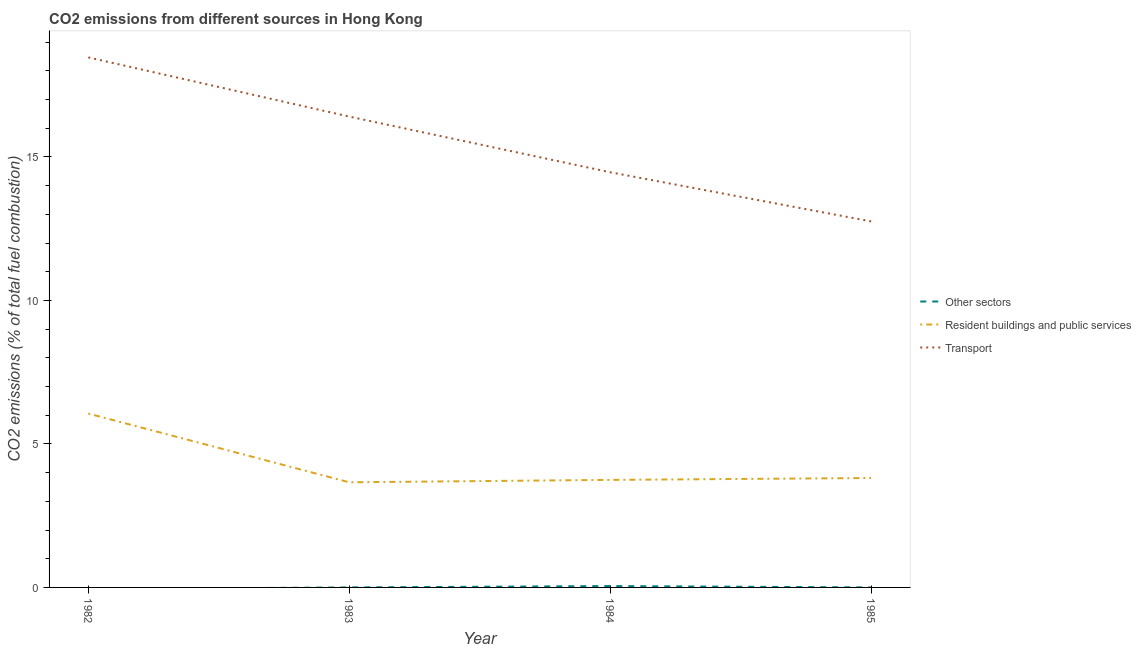What is the percentage of co2 emissions from transport in 1983?
Your answer should be compact. 16.41. Across all years, what is the maximum percentage of co2 emissions from transport?
Give a very brief answer. 18.47. Across all years, what is the minimum percentage of co2 emissions from transport?
Offer a very short reply. 12.76. What is the total percentage of co2 emissions from resident buildings and public services in the graph?
Offer a terse response. 17.28. What is the difference between the percentage of co2 emissions from transport in 1983 and that in 1984?
Make the answer very short. 1.94. What is the difference between the percentage of co2 emissions from other sectors in 1983 and the percentage of co2 emissions from resident buildings and public services in 1984?
Keep it short and to the point. -3.75. What is the average percentage of co2 emissions from other sectors per year?
Keep it short and to the point. 0.01. In the year 1985, what is the difference between the percentage of co2 emissions from resident buildings and public services and percentage of co2 emissions from transport?
Offer a terse response. -8.94. What is the ratio of the percentage of co2 emissions from transport in 1982 to that in 1985?
Offer a terse response. 1.45. Is the percentage of co2 emissions from resident buildings and public services in 1984 less than that in 1985?
Your answer should be compact. Yes. What is the difference between the highest and the second highest percentage of co2 emissions from transport?
Your response must be concise. 2.06. What is the difference between the highest and the lowest percentage of co2 emissions from other sectors?
Make the answer very short. 0.05. Is the sum of the percentage of co2 emissions from transport in 1982 and 1984 greater than the maximum percentage of co2 emissions from other sectors across all years?
Give a very brief answer. Yes. Does the percentage of co2 emissions from transport monotonically increase over the years?
Provide a succinct answer. No. Is the percentage of co2 emissions from transport strictly greater than the percentage of co2 emissions from resident buildings and public services over the years?
Give a very brief answer. Yes. Is the percentage of co2 emissions from transport strictly less than the percentage of co2 emissions from other sectors over the years?
Keep it short and to the point. No. How many lines are there?
Your answer should be very brief. 3. Are the values on the major ticks of Y-axis written in scientific E-notation?
Offer a very short reply. No. Does the graph contain grids?
Provide a succinct answer. No. What is the title of the graph?
Your answer should be compact. CO2 emissions from different sources in Hong Kong. Does "New Zealand" appear as one of the legend labels in the graph?
Keep it short and to the point. No. What is the label or title of the X-axis?
Ensure brevity in your answer.  Year. What is the label or title of the Y-axis?
Your answer should be very brief. CO2 emissions (% of total fuel combustion). What is the CO2 emissions (% of total fuel combustion) of Resident buildings and public services in 1982?
Keep it short and to the point. 6.06. What is the CO2 emissions (% of total fuel combustion) of Transport in 1982?
Your answer should be very brief. 18.47. What is the CO2 emissions (% of total fuel combustion) of Other sectors in 1983?
Provide a short and direct response. 0. What is the CO2 emissions (% of total fuel combustion) of Resident buildings and public services in 1983?
Give a very brief answer. 3.66. What is the CO2 emissions (% of total fuel combustion) in Transport in 1983?
Your response must be concise. 16.41. What is the CO2 emissions (% of total fuel combustion) in Other sectors in 1984?
Keep it short and to the point. 0.05. What is the CO2 emissions (% of total fuel combustion) in Resident buildings and public services in 1984?
Offer a very short reply. 3.75. What is the CO2 emissions (% of total fuel combustion) of Transport in 1984?
Provide a short and direct response. 14.47. What is the CO2 emissions (% of total fuel combustion) in Other sectors in 1985?
Your response must be concise. 0. What is the CO2 emissions (% of total fuel combustion) of Resident buildings and public services in 1985?
Provide a short and direct response. 3.81. What is the CO2 emissions (% of total fuel combustion) in Transport in 1985?
Ensure brevity in your answer.  12.76. Across all years, what is the maximum CO2 emissions (% of total fuel combustion) in Other sectors?
Provide a short and direct response. 0.05. Across all years, what is the maximum CO2 emissions (% of total fuel combustion) in Resident buildings and public services?
Ensure brevity in your answer.  6.06. Across all years, what is the maximum CO2 emissions (% of total fuel combustion) of Transport?
Provide a short and direct response. 18.47. Across all years, what is the minimum CO2 emissions (% of total fuel combustion) in Resident buildings and public services?
Keep it short and to the point. 3.66. Across all years, what is the minimum CO2 emissions (% of total fuel combustion) in Transport?
Make the answer very short. 12.76. What is the total CO2 emissions (% of total fuel combustion) in Other sectors in the graph?
Your response must be concise. 0.05. What is the total CO2 emissions (% of total fuel combustion) of Resident buildings and public services in the graph?
Make the answer very short. 17.28. What is the total CO2 emissions (% of total fuel combustion) in Transport in the graph?
Offer a terse response. 62.1. What is the difference between the CO2 emissions (% of total fuel combustion) of Resident buildings and public services in 1982 and that in 1983?
Your response must be concise. 2.4. What is the difference between the CO2 emissions (% of total fuel combustion) in Transport in 1982 and that in 1983?
Offer a terse response. 2.06. What is the difference between the CO2 emissions (% of total fuel combustion) in Resident buildings and public services in 1982 and that in 1984?
Offer a terse response. 2.31. What is the difference between the CO2 emissions (% of total fuel combustion) in Transport in 1982 and that in 1984?
Provide a short and direct response. 4. What is the difference between the CO2 emissions (% of total fuel combustion) of Resident buildings and public services in 1982 and that in 1985?
Give a very brief answer. 2.25. What is the difference between the CO2 emissions (% of total fuel combustion) in Transport in 1982 and that in 1985?
Make the answer very short. 5.72. What is the difference between the CO2 emissions (% of total fuel combustion) of Resident buildings and public services in 1983 and that in 1984?
Offer a very short reply. -0.08. What is the difference between the CO2 emissions (% of total fuel combustion) of Transport in 1983 and that in 1984?
Offer a terse response. 1.94. What is the difference between the CO2 emissions (% of total fuel combustion) of Resident buildings and public services in 1983 and that in 1985?
Ensure brevity in your answer.  -0.15. What is the difference between the CO2 emissions (% of total fuel combustion) of Transport in 1983 and that in 1985?
Ensure brevity in your answer.  3.65. What is the difference between the CO2 emissions (% of total fuel combustion) in Resident buildings and public services in 1984 and that in 1985?
Keep it short and to the point. -0.07. What is the difference between the CO2 emissions (% of total fuel combustion) of Transport in 1984 and that in 1985?
Keep it short and to the point. 1.71. What is the difference between the CO2 emissions (% of total fuel combustion) of Resident buildings and public services in 1982 and the CO2 emissions (% of total fuel combustion) of Transport in 1983?
Your answer should be compact. -10.35. What is the difference between the CO2 emissions (% of total fuel combustion) of Resident buildings and public services in 1982 and the CO2 emissions (% of total fuel combustion) of Transport in 1984?
Give a very brief answer. -8.41. What is the difference between the CO2 emissions (% of total fuel combustion) of Resident buildings and public services in 1982 and the CO2 emissions (% of total fuel combustion) of Transport in 1985?
Ensure brevity in your answer.  -6.7. What is the difference between the CO2 emissions (% of total fuel combustion) of Resident buildings and public services in 1983 and the CO2 emissions (% of total fuel combustion) of Transport in 1984?
Make the answer very short. -10.81. What is the difference between the CO2 emissions (% of total fuel combustion) of Resident buildings and public services in 1983 and the CO2 emissions (% of total fuel combustion) of Transport in 1985?
Your answer should be compact. -9.09. What is the difference between the CO2 emissions (% of total fuel combustion) in Other sectors in 1984 and the CO2 emissions (% of total fuel combustion) in Resident buildings and public services in 1985?
Offer a very short reply. -3.77. What is the difference between the CO2 emissions (% of total fuel combustion) of Other sectors in 1984 and the CO2 emissions (% of total fuel combustion) of Transport in 1985?
Your response must be concise. -12.71. What is the difference between the CO2 emissions (% of total fuel combustion) in Resident buildings and public services in 1984 and the CO2 emissions (% of total fuel combustion) in Transport in 1985?
Give a very brief answer. -9.01. What is the average CO2 emissions (% of total fuel combustion) of Other sectors per year?
Your response must be concise. 0.01. What is the average CO2 emissions (% of total fuel combustion) in Resident buildings and public services per year?
Offer a very short reply. 4.32. What is the average CO2 emissions (% of total fuel combustion) in Transport per year?
Provide a succinct answer. 15.53. In the year 1982, what is the difference between the CO2 emissions (% of total fuel combustion) in Resident buildings and public services and CO2 emissions (% of total fuel combustion) in Transport?
Give a very brief answer. -12.41. In the year 1983, what is the difference between the CO2 emissions (% of total fuel combustion) of Resident buildings and public services and CO2 emissions (% of total fuel combustion) of Transport?
Make the answer very short. -12.75. In the year 1984, what is the difference between the CO2 emissions (% of total fuel combustion) in Other sectors and CO2 emissions (% of total fuel combustion) in Resident buildings and public services?
Your answer should be very brief. -3.7. In the year 1984, what is the difference between the CO2 emissions (% of total fuel combustion) of Other sectors and CO2 emissions (% of total fuel combustion) of Transport?
Provide a short and direct response. -14.42. In the year 1984, what is the difference between the CO2 emissions (% of total fuel combustion) of Resident buildings and public services and CO2 emissions (% of total fuel combustion) of Transport?
Offer a very short reply. -10.72. In the year 1985, what is the difference between the CO2 emissions (% of total fuel combustion) in Resident buildings and public services and CO2 emissions (% of total fuel combustion) in Transport?
Give a very brief answer. -8.94. What is the ratio of the CO2 emissions (% of total fuel combustion) in Resident buildings and public services in 1982 to that in 1983?
Provide a short and direct response. 1.65. What is the ratio of the CO2 emissions (% of total fuel combustion) in Transport in 1982 to that in 1983?
Provide a succinct answer. 1.13. What is the ratio of the CO2 emissions (% of total fuel combustion) of Resident buildings and public services in 1982 to that in 1984?
Offer a terse response. 1.62. What is the ratio of the CO2 emissions (% of total fuel combustion) of Transport in 1982 to that in 1984?
Your response must be concise. 1.28. What is the ratio of the CO2 emissions (% of total fuel combustion) of Resident buildings and public services in 1982 to that in 1985?
Your answer should be compact. 1.59. What is the ratio of the CO2 emissions (% of total fuel combustion) of Transport in 1982 to that in 1985?
Make the answer very short. 1.45. What is the ratio of the CO2 emissions (% of total fuel combustion) of Resident buildings and public services in 1983 to that in 1984?
Offer a very short reply. 0.98. What is the ratio of the CO2 emissions (% of total fuel combustion) of Transport in 1983 to that in 1984?
Keep it short and to the point. 1.13. What is the ratio of the CO2 emissions (% of total fuel combustion) in Resident buildings and public services in 1983 to that in 1985?
Ensure brevity in your answer.  0.96. What is the ratio of the CO2 emissions (% of total fuel combustion) in Transport in 1983 to that in 1985?
Keep it short and to the point. 1.29. What is the ratio of the CO2 emissions (% of total fuel combustion) of Resident buildings and public services in 1984 to that in 1985?
Ensure brevity in your answer.  0.98. What is the ratio of the CO2 emissions (% of total fuel combustion) in Transport in 1984 to that in 1985?
Keep it short and to the point. 1.13. What is the difference between the highest and the second highest CO2 emissions (% of total fuel combustion) in Resident buildings and public services?
Your answer should be compact. 2.25. What is the difference between the highest and the second highest CO2 emissions (% of total fuel combustion) of Transport?
Ensure brevity in your answer.  2.06. What is the difference between the highest and the lowest CO2 emissions (% of total fuel combustion) of Other sectors?
Offer a terse response. 0.05. What is the difference between the highest and the lowest CO2 emissions (% of total fuel combustion) in Resident buildings and public services?
Your answer should be compact. 2.4. What is the difference between the highest and the lowest CO2 emissions (% of total fuel combustion) of Transport?
Give a very brief answer. 5.72. 